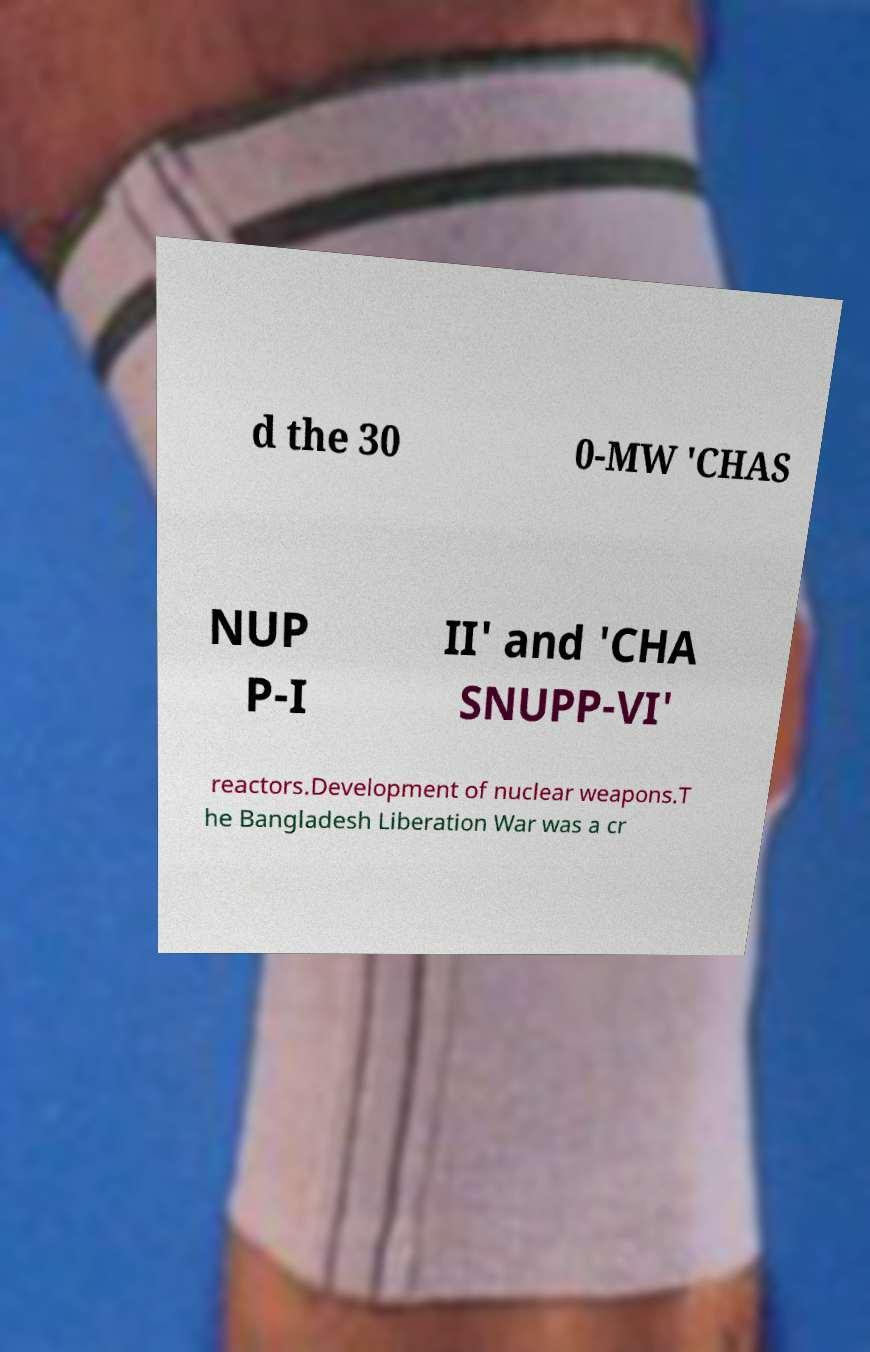What messages or text are displayed in this image? I need them in a readable, typed format. d the 30 0-MW 'CHAS NUP P-I II' and 'CHA SNUPP-VI' reactors.Development of nuclear weapons.T he Bangladesh Liberation War was a cr 